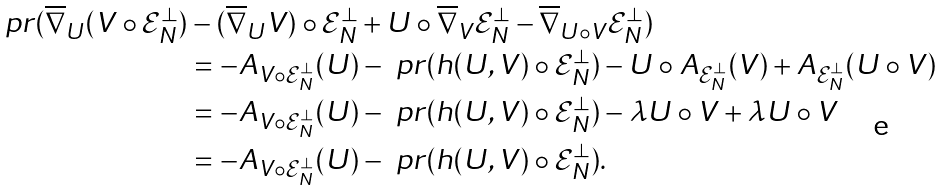<formula> <loc_0><loc_0><loc_500><loc_500>\ p r ( \overline { \nabla } _ { U } ( V \circ \mathcal { E } _ { N } ^ { \bot } ) & - ( \overline { \nabla } _ { U } V ) \circ \mathcal { E } _ { N } ^ { \bot } + U \circ \overline { \nabla } _ { V } \mathcal { E } _ { N } ^ { \bot } - \overline { \nabla } _ { U \circ V } \mathcal { E } _ { N } ^ { \bot } ) \\ & = - A _ { V \circ \mathcal { E } _ { N } ^ { \bot } } ( U ) - \ p r ( h ( U , V ) \circ \mathcal { E } _ { N } ^ { \bot } ) - U \circ A _ { \mathcal { E } _ { N } ^ { \bot } } ( V ) + A _ { \mathcal { E } _ { N } ^ { \bot } } ( U \circ V ) \\ & = - A _ { V \circ \mathcal { E } _ { N } ^ { \bot } } ( U ) - \ p r ( h ( U , V ) \circ \mathcal { E } _ { N } ^ { \bot } ) - \lambda U \circ V + \lambda U \circ V \\ & = - A _ { V \circ \mathcal { E } _ { N } ^ { \bot } } ( U ) - \ p r ( h ( U , V ) \circ \mathcal { E } _ { N } ^ { \bot } ) .</formula> 